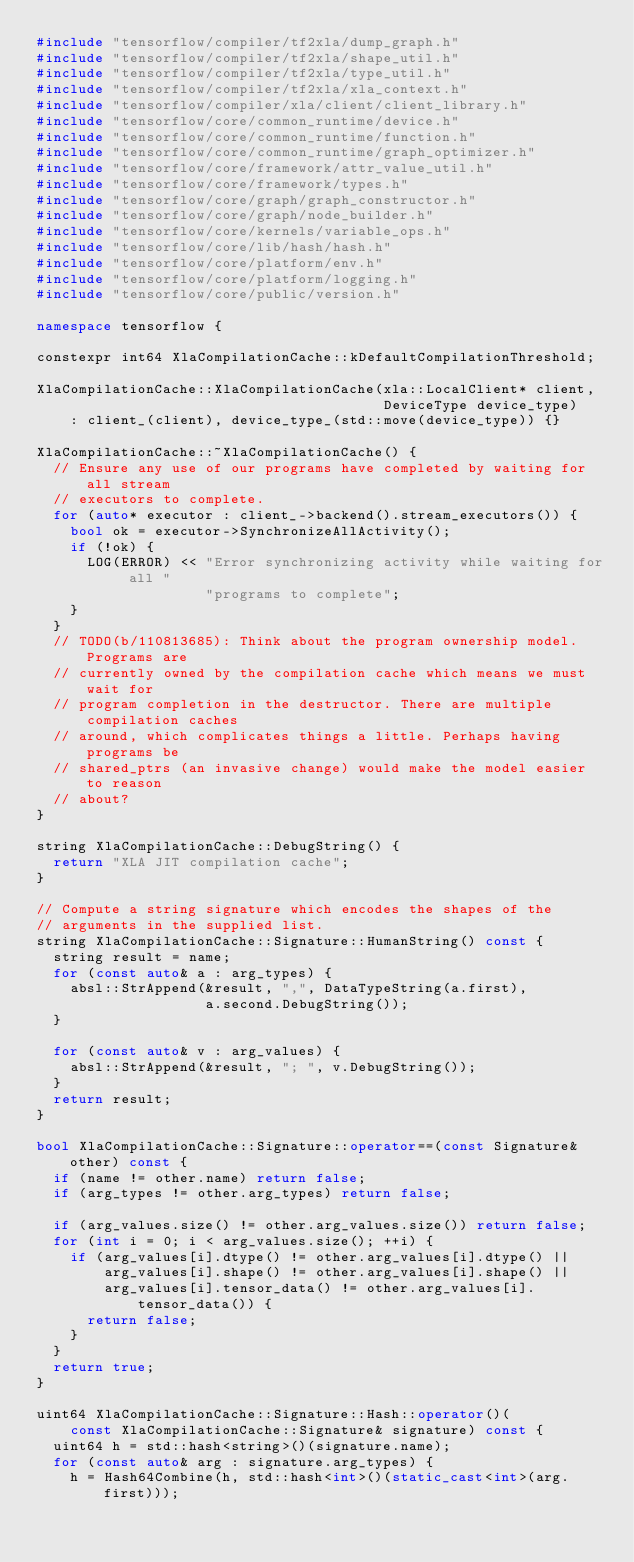Convert code to text. <code><loc_0><loc_0><loc_500><loc_500><_C++_>#include "tensorflow/compiler/tf2xla/dump_graph.h"
#include "tensorflow/compiler/tf2xla/shape_util.h"
#include "tensorflow/compiler/tf2xla/type_util.h"
#include "tensorflow/compiler/tf2xla/xla_context.h"
#include "tensorflow/compiler/xla/client/client_library.h"
#include "tensorflow/core/common_runtime/device.h"
#include "tensorflow/core/common_runtime/function.h"
#include "tensorflow/core/common_runtime/graph_optimizer.h"
#include "tensorflow/core/framework/attr_value_util.h"
#include "tensorflow/core/framework/types.h"
#include "tensorflow/core/graph/graph_constructor.h"
#include "tensorflow/core/graph/node_builder.h"
#include "tensorflow/core/kernels/variable_ops.h"
#include "tensorflow/core/lib/hash/hash.h"
#include "tensorflow/core/platform/env.h"
#include "tensorflow/core/platform/logging.h"
#include "tensorflow/core/public/version.h"

namespace tensorflow {

constexpr int64 XlaCompilationCache::kDefaultCompilationThreshold;

XlaCompilationCache::XlaCompilationCache(xla::LocalClient* client,
                                         DeviceType device_type)
    : client_(client), device_type_(std::move(device_type)) {}

XlaCompilationCache::~XlaCompilationCache() {
  // Ensure any use of our programs have completed by waiting for all stream
  // executors to complete.
  for (auto* executor : client_->backend().stream_executors()) {
    bool ok = executor->SynchronizeAllActivity();
    if (!ok) {
      LOG(ERROR) << "Error synchronizing activity while waiting for all "
                    "programs to complete";
    }
  }
  // TODO(b/110813685): Think about the program ownership model. Programs are
  // currently owned by the compilation cache which means we must wait for
  // program completion in the destructor. There are multiple compilation caches
  // around, which complicates things a little. Perhaps having programs be
  // shared_ptrs (an invasive change) would make the model easier to reason
  // about?
}

string XlaCompilationCache::DebugString() {
  return "XLA JIT compilation cache";
}

// Compute a string signature which encodes the shapes of the
// arguments in the supplied list.
string XlaCompilationCache::Signature::HumanString() const {
  string result = name;
  for (const auto& a : arg_types) {
    absl::StrAppend(&result, ",", DataTypeString(a.first),
                    a.second.DebugString());
  }

  for (const auto& v : arg_values) {
    absl::StrAppend(&result, "; ", v.DebugString());
  }
  return result;
}

bool XlaCompilationCache::Signature::operator==(const Signature& other) const {
  if (name != other.name) return false;
  if (arg_types != other.arg_types) return false;

  if (arg_values.size() != other.arg_values.size()) return false;
  for (int i = 0; i < arg_values.size(); ++i) {
    if (arg_values[i].dtype() != other.arg_values[i].dtype() ||
        arg_values[i].shape() != other.arg_values[i].shape() ||
        arg_values[i].tensor_data() != other.arg_values[i].tensor_data()) {
      return false;
    }
  }
  return true;
}

uint64 XlaCompilationCache::Signature::Hash::operator()(
    const XlaCompilationCache::Signature& signature) const {
  uint64 h = std::hash<string>()(signature.name);
  for (const auto& arg : signature.arg_types) {
    h = Hash64Combine(h, std::hash<int>()(static_cast<int>(arg.first)));</code> 